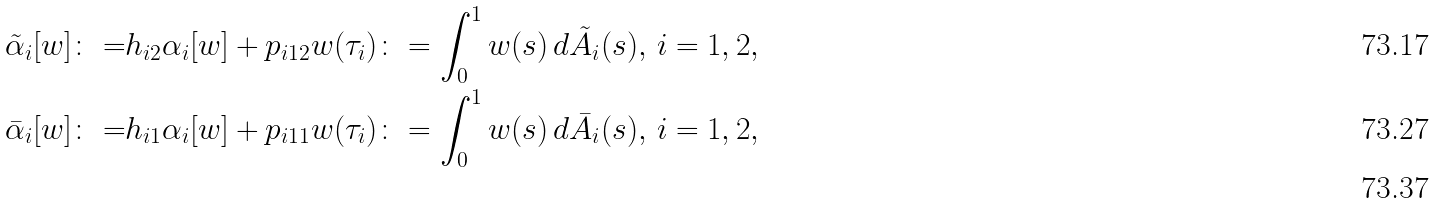Convert formula to latex. <formula><loc_0><loc_0><loc_500><loc_500>\tilde { \alpha } _ { i } [ w ] \colon = & h _ { i 2 } \alpha _ { i } [ w ] + p _ { i 1 2 } w ( \tau _ { i } ) \colon = \int _ { 0 } ^ { 1 } w ( s ) \, d \tilde { A } _ { i } ( s ) , \, i = 1 , 2 , \\ \bar { \alpha } _ { i } [ w ] \colon = & h _ { i 1 } \alpha _ { i } [ w ] + p _ { i 1 1 } w ( \tau _ { i } ) \colon = \int _ { 0 } ^ { 1 } w ( s ) \, d \bar { A } _ { i } ( s ) , \, i = 1 , 2 , \\</formula> 